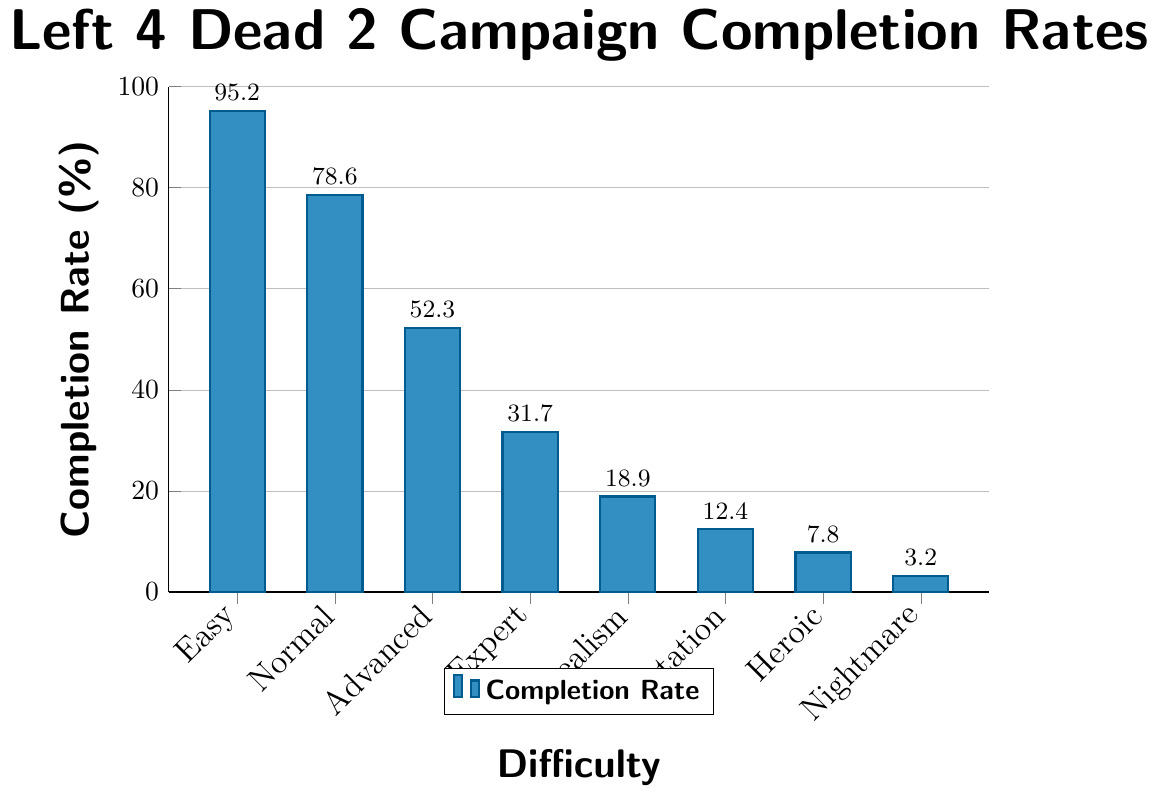Which difficulty level has the highest campaign completion rate? The bar representing the "Easy" difficulty is the tallest, indicating the highest completion rate of 95.2%.
Answer: Easy Which difficulty level has the lowest campaign completion rate? The bar representing the "Nightmare" difficulty is the shortest, indicating the lowest completion rate of 3.2%.
Answer: Nightmare What is the difference in campaign completion rates between "Easy" and "Expert" difficulties? The completion rate for "Easy" is 95.2%, and for "Expert" it is 31.7%. The difference is 95.2% - 31.7% = 63.5%.
Answer: 63.5% What is the sum of completion rates for "Realism", "Mutation", and "Heroic" difficulties? The completion rates are 18.9% (Realism), 12.4% (Mutation), and 7.8% (Heroic). The sum is 18.9% + 12.4% + 7.8% = 39.1%.
Answer: 39.1% Rank the difficulties from highest to lowest completion rate. The completion rates need to be sorted: Easy (95.2%), Normal (78.6%), Advanced (52.3%), Expert (31.7%), Realism (18.9%), Mutation (12.4%), Heroic (7.8%), Nightmare (3.2%).
Answer: Easy, Normal, Advanced, Expert, Realism, Mutation, Heroic, Nightmare Which difficulties have completion rates less than 20%? The bars for "Realism" (18.9%), "Mutation" (12.4%), "Heroic" (7.8%), and "Nightmare" (3.2%) are less than the 20% mark.
Answer: Realism, Mutation, Heroic, Nightmare How much higher is the completion rate for "Normal" compared to "Advanced"? The completion rate for "Normal" is 78.6%, and for "Advanced" it is 52.3%. The difference is 78.6% - 52.3% = 26.3%.
Answer: 26.3% Calculate the average completion rate for all difficulty levels. The completion rates sum up to 95.2% + 78.6% + 52.3% + 31.7% + 18.9% + 12.4% + 7.8% + 3.2% = 300.1%. Dividing by 8 difficulties, the average is 300.1% / 8 = 37.5125%.
Answer: 37.5% Which difficulty level is visually represented by a bar of medium height? The "Advanced" difficulty level has a bar that is medium height compared to the others with a completion rate of 52.3%.
Answer: Advanced 